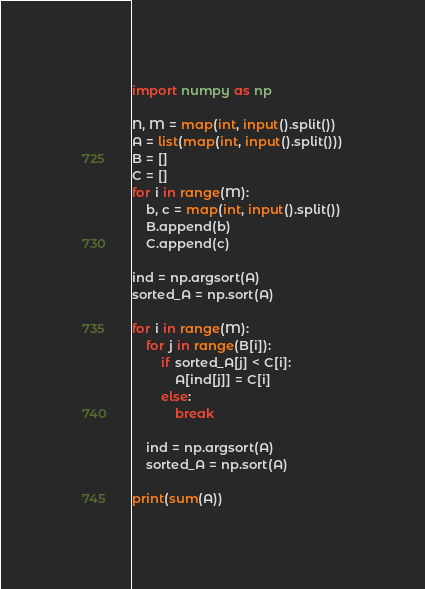<code> <loc_0><loc_0><loc_500><loc_500><_Python_>import numpy as np

N, M = map(int, input().split())
A = list(map(int, input().split()))
B = []
C = []
for i in range(M):
    b, c = map(int, input().split())
    B.append(b)
    C.append(c)

ind = np.argsort(A)
sorted_A = np.sort(A)

for i in range(M):
    for j in range(B[i]):
        if sorted_A[j] < C[i]:
            A[ind[j]] = C[i]
        else:
            break

    ind = np.argsort(A)
    sorted_A = np.sort(A)

print(sum(A))
</code> 